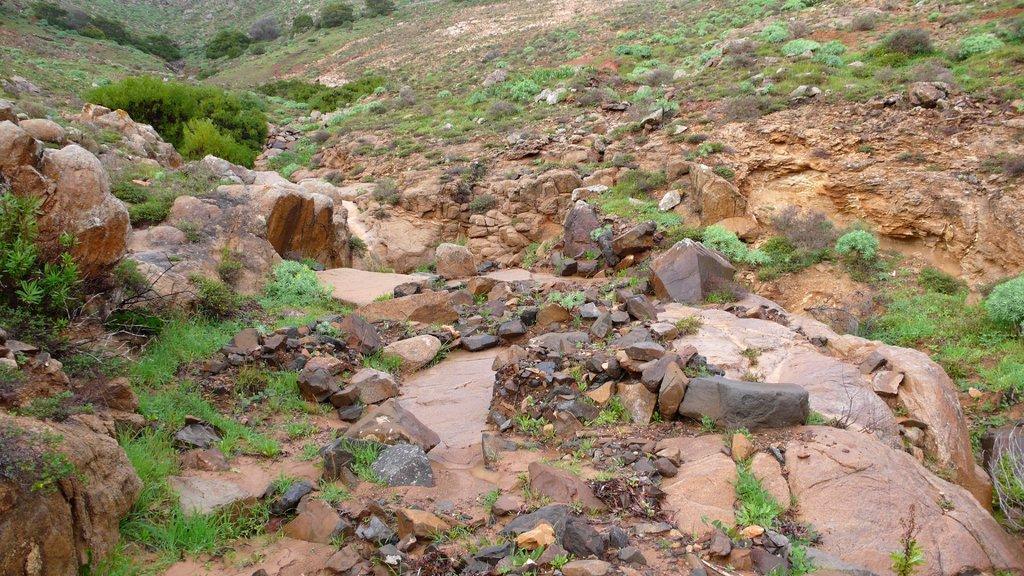Can you describe this image briefly? In this image I can see number of stones and grass on the ground. 